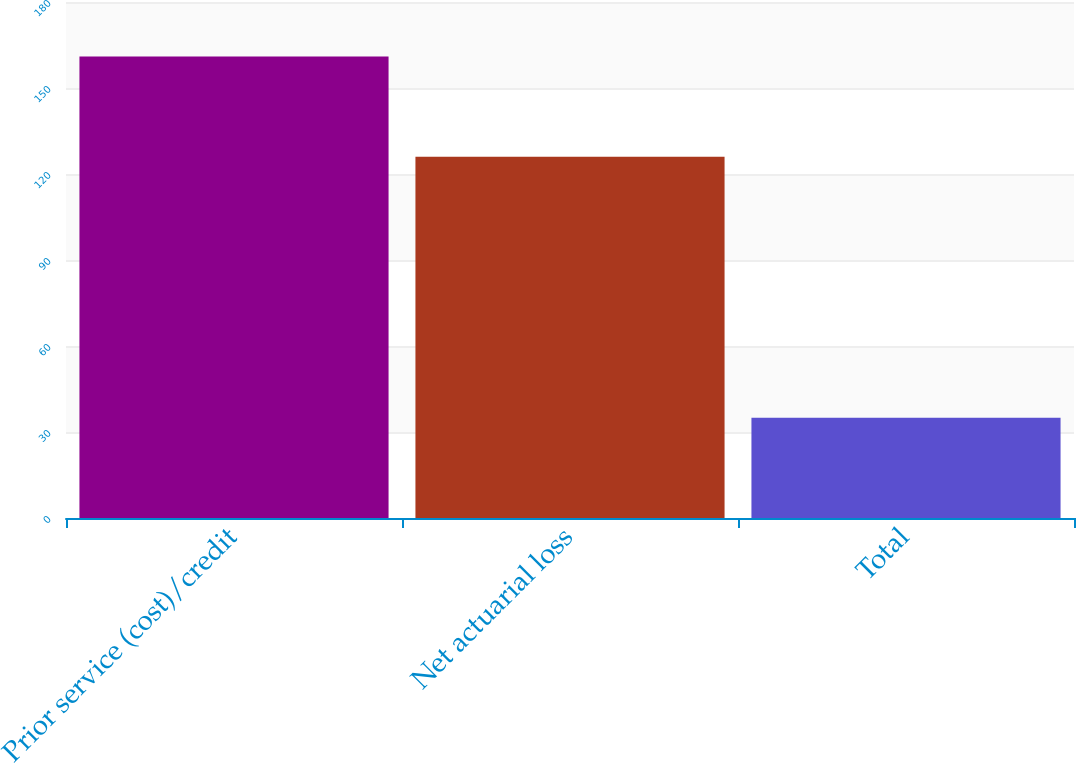Convert chart to OTSL. <chart><loc_0><loc_0><loc_500><loc_500><bar_chart><fcel>Prior service (cost)/credit<fcel>Net actuarial loss<fcel>Total<nl><fcel>161<fcel>126<fcel>35<nl></chart> 